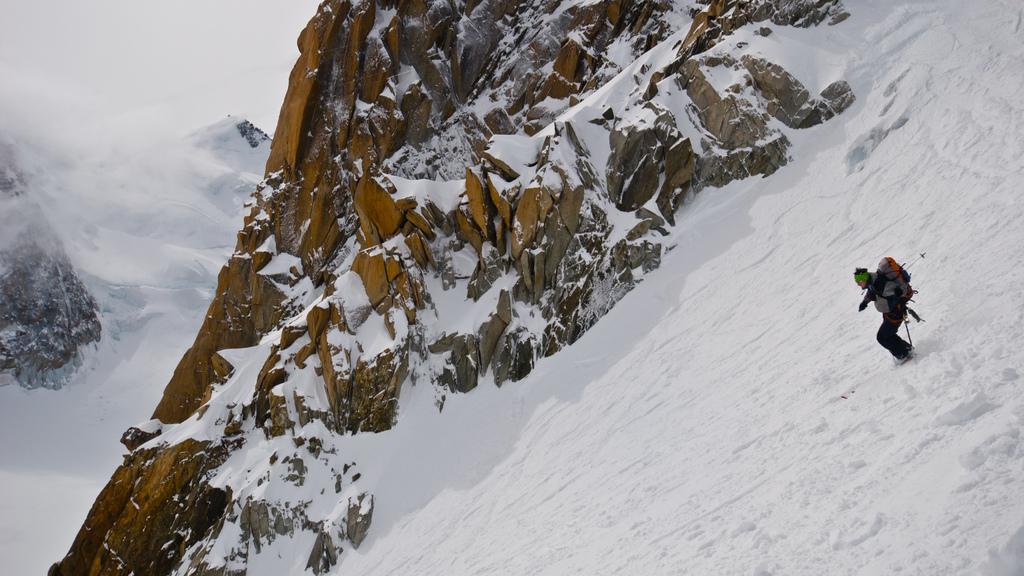How would you summarize this image in a sentence or two? On the right side of the image we can see one person is skiing on the snow. And he is wearing a backpack and a few other objects. In the background, we can see hills, snow and a few other objects. 